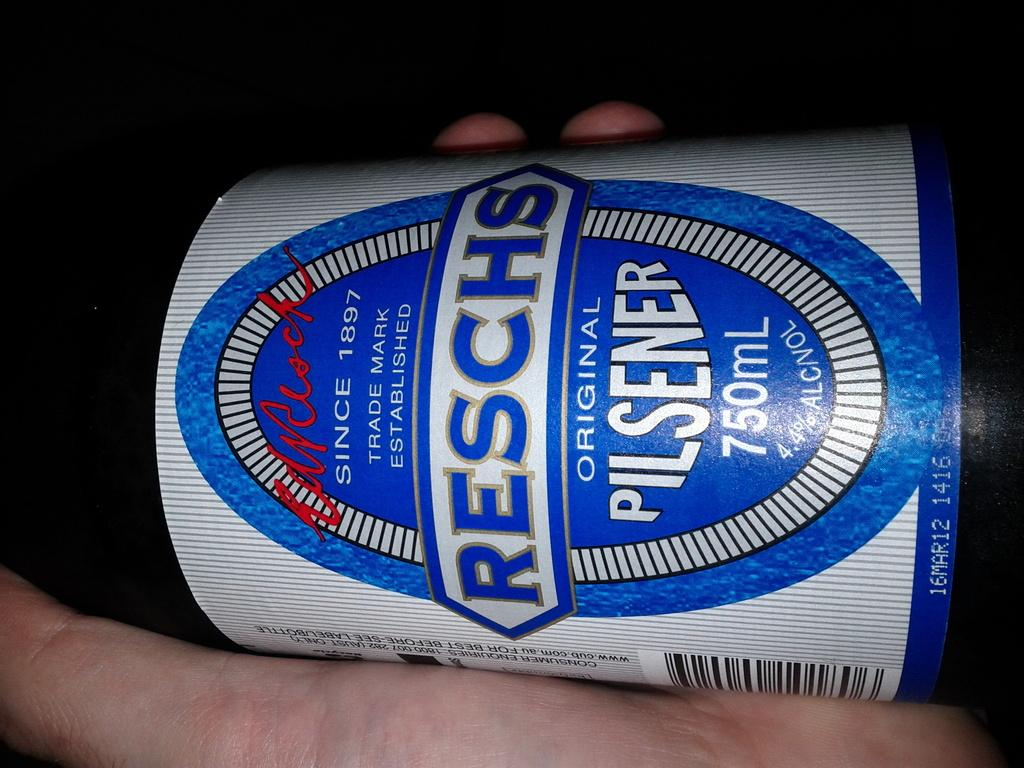<image>
Present a compact description of the photo's key features. A person is holding a bottle of beer that says Reschs Original Pilsner. 